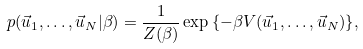<formula> <loc_0><loc_0><loc_500><loc_500>p ( \vec { u } _ { 1 } , \dots , \vec { u } _ { N } | \beta ) = \frac { 1 } { Z ( \beta ) } \exp { \left \{ - \beta V ( \vec { u } _ { 1 } , \dots , \vec { u } _ { N } ) \right \} } ,</formula> 